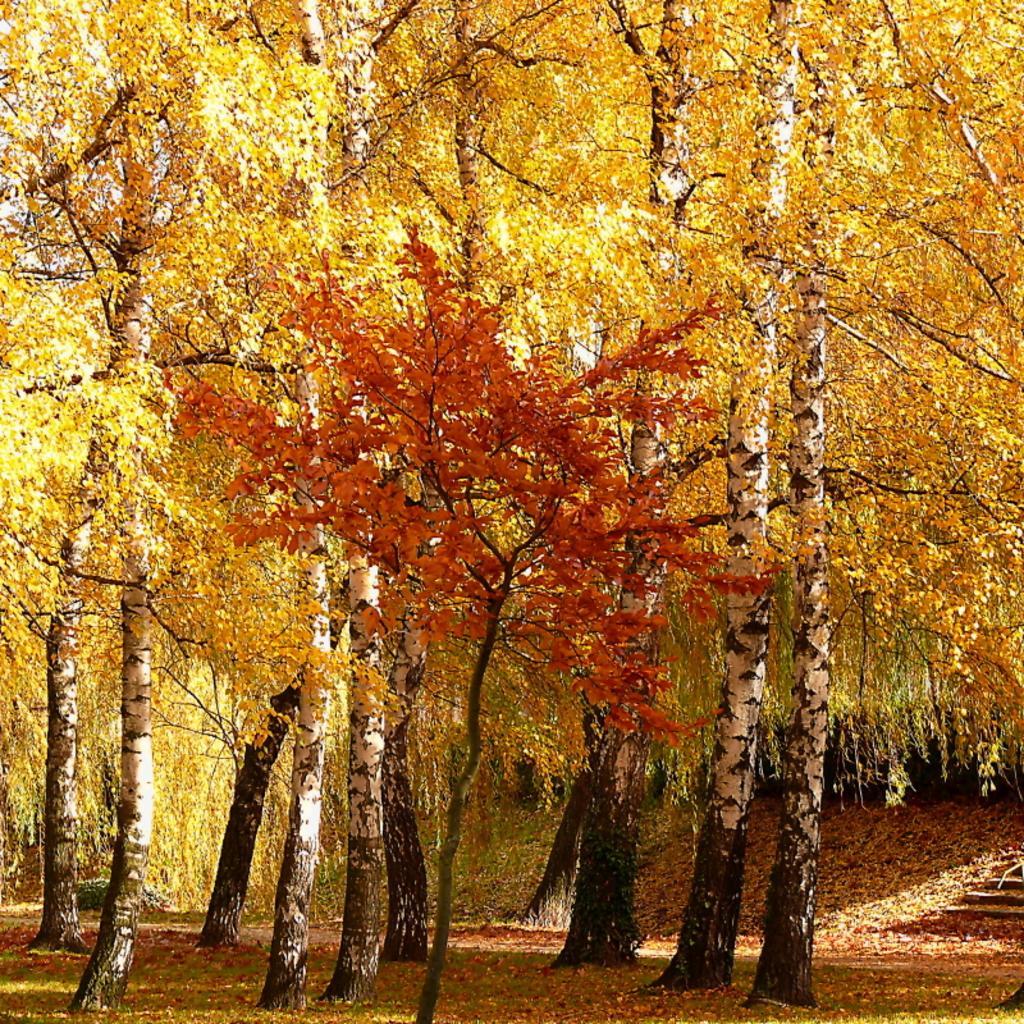Describe this image in one or two sentences. In this image I can see many tree on the ground. The leaves are in yellow and orange colors. 